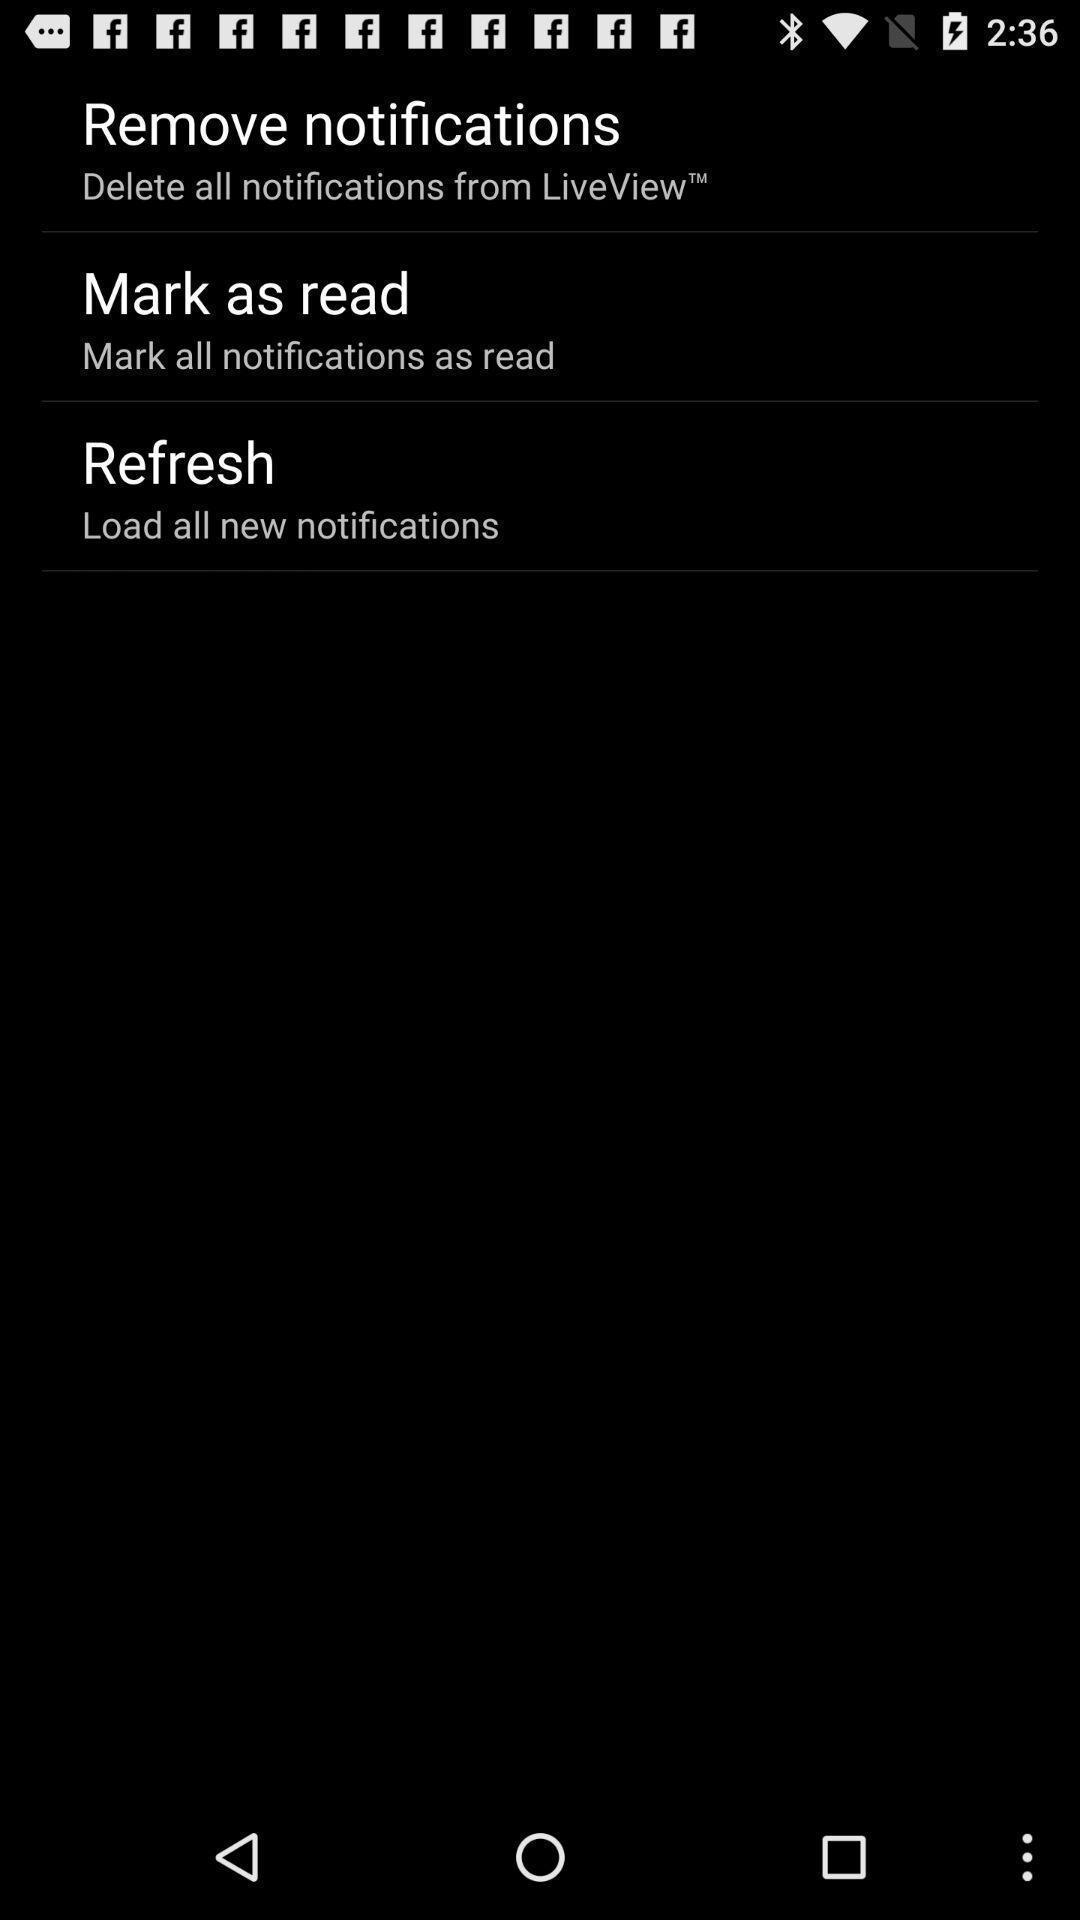Summarize the main components in this picture. Screen shows to remove notifications. 